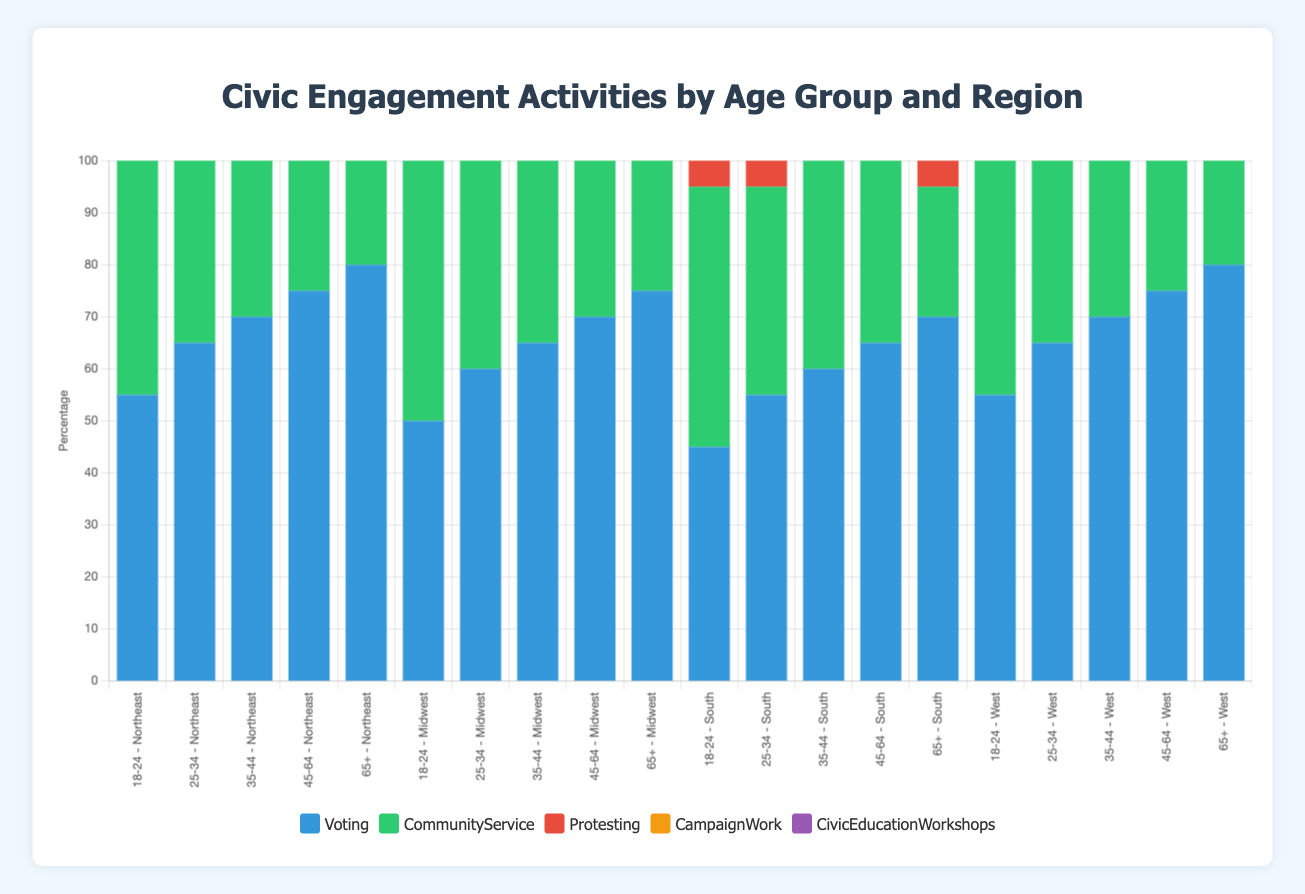Which age group in the Northeast has the highest percentage of Voting? To find this, look at the "Voting" bar section for each age group in the Northeast region and identify which one is the tallest. The "65+" group in the Northeast has an 80% participation rate, which is the highest.
Answer: 65+ Compare the Community Service percentages between the 18-24 age group in the West and South regions. Which region has a higher percentage? Look at the "CommunityService" bar section for the 18-24 age groups in the West and South regions. The West region has a Community Service percentage of 65%, while the South has 50%. Comparing these, the West has a higher percentage.
Answer: West What is the sum of the percentage values for all activities for the 25-34 age group in the Midwest region? Add all the activity percentages for the 25-34 age group in the Midwest: Voting (60%), Community Service (45%), Protesting (30%), Campaign Work (15%), and Civic Education Workshops (25%). The total is 60 + 45 + 30 + 15 + 25 = 175%.
Answer: 175% Which region has the lowest percentage of Protesting among the 45-64 age group? Look at the "Protesting" bar section for the 45-64 age groups in all regions and identify the lowest percentage. The Northeast region has the lowest with 10%.
Answer: Northeast Compare the height of the "Campaign Work" bar for the 35-44 age group in the South with the 45-64 age group in the Midwest. Which one is taller? Assess the height of the "Campaign Work" bar for the 35-44 age group in the South (18%) and compare it with the 45-64 age group in the Midwest (25%). The Midwest bar is taller.
Answer: Midwest What is the average percentage of Voting across all age groups in the West region? Calculate the average by summing the Voting percentages for all age groups in the West and dividing by the number of age groups: (55 + 65 + 70 + 75 + 80) / 5 = 345 / 5 = 69%.
Answer: 69% Which age group in the South participates the least in Civic Education Workshops? Look at the "CivicEducationWorkshops" bar section for each age group in the South and identify the shortest one. The 18-24 age group has the shortest bar with 15%.
Answer: 18-24 How much more is the Community Service percentage for the 35-44 age group in the Northeast compared to the Midwest? Subtract the Community Service percentage of the 35-44 age group in the Midwest (50%) from that in the Northeast (55%). The difference is 55 - 50 = 5%.
Answer: 5% more In which region is the 18-24 age group most active in Protesting? Identify the region where the "Protesting" bar section for the 18-24 age group is the tallest. The West region has the highest percentage of 45%.
Answer: West 